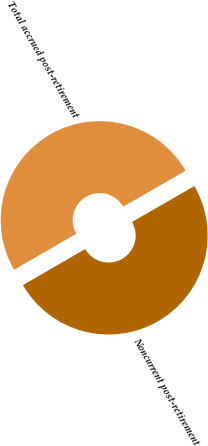Convert chart. <chart><loc_0><loc_0><loc_500><loc_500><pie_chart><fcel>Noncurrent post-retirement<fcel>Total accrued post-retirement<nl><fcel>49.96%<fcel>50.04%<nl></chart> 